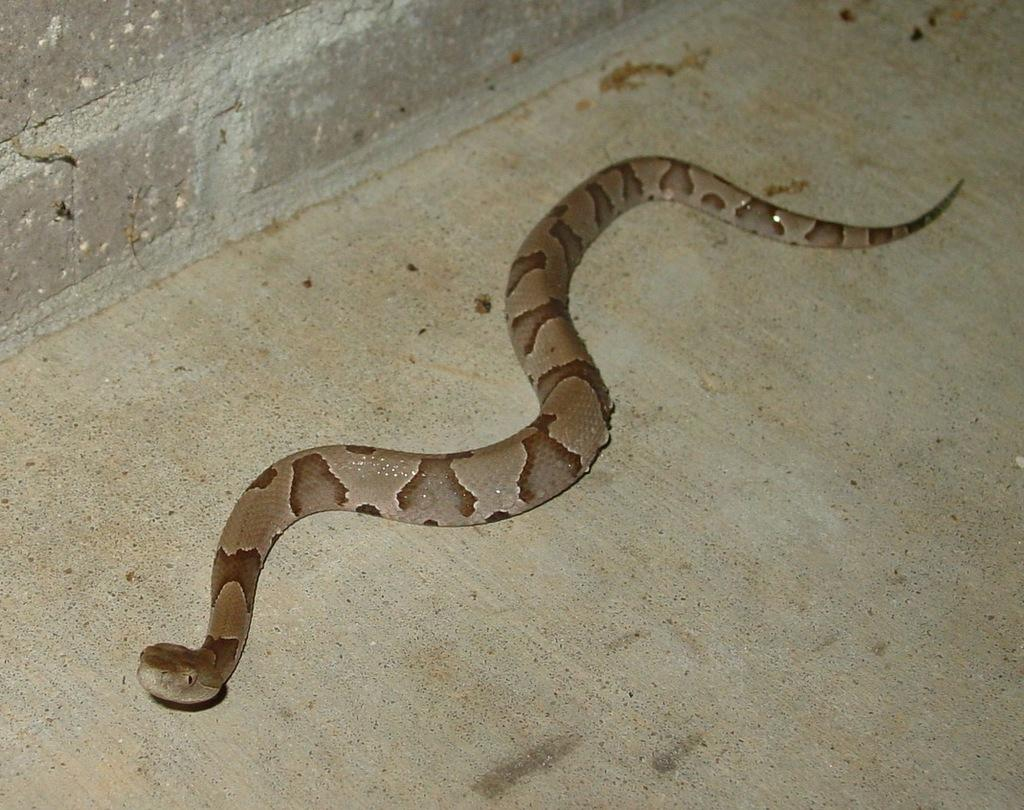What is the main subject in the center of the image? There is a snake in the center of the image. What type of meal is Uncle John preparing in the image? There is no reference to a meal or Uncle John in the image; it only features a snake in the center. 